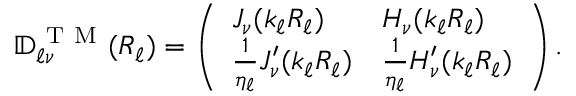Convert formula to latex. <formula><loc_0><loc_0><loc_500><loc_500>\mathbb { D } _ { \ell \nu } ^ { T M } ( R _ { \ell } ) = \left ( \begin{array} { l l } { J _ { \nu } ( k _ { \ell } R _ { \ell } ) } & { H _ { \nu } ( k _ { \ell } R _ { \ell } ) } \\ { \frac { 1 } { \eta _ { \ell } } J _ { \nu } ^ { \prime } ( k _ { \ell } R _ { \ell } ) } & { \frac { 1 } { \eta _ { \ell } } H _ { \nu } ^ { \prime } ( k _ { \ell } R _ { \ell } ) } \end{array} \right ) .</formula> 